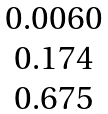Convert formula to latex. <formula><loc_0><loc_0><loc_500><loc_500>\begin{matrix} 0 . 0 0 6 0 \\ 0 . 1 7 4 \\ 0 . 6 7 5 \\ \end{matrix}</formula> 